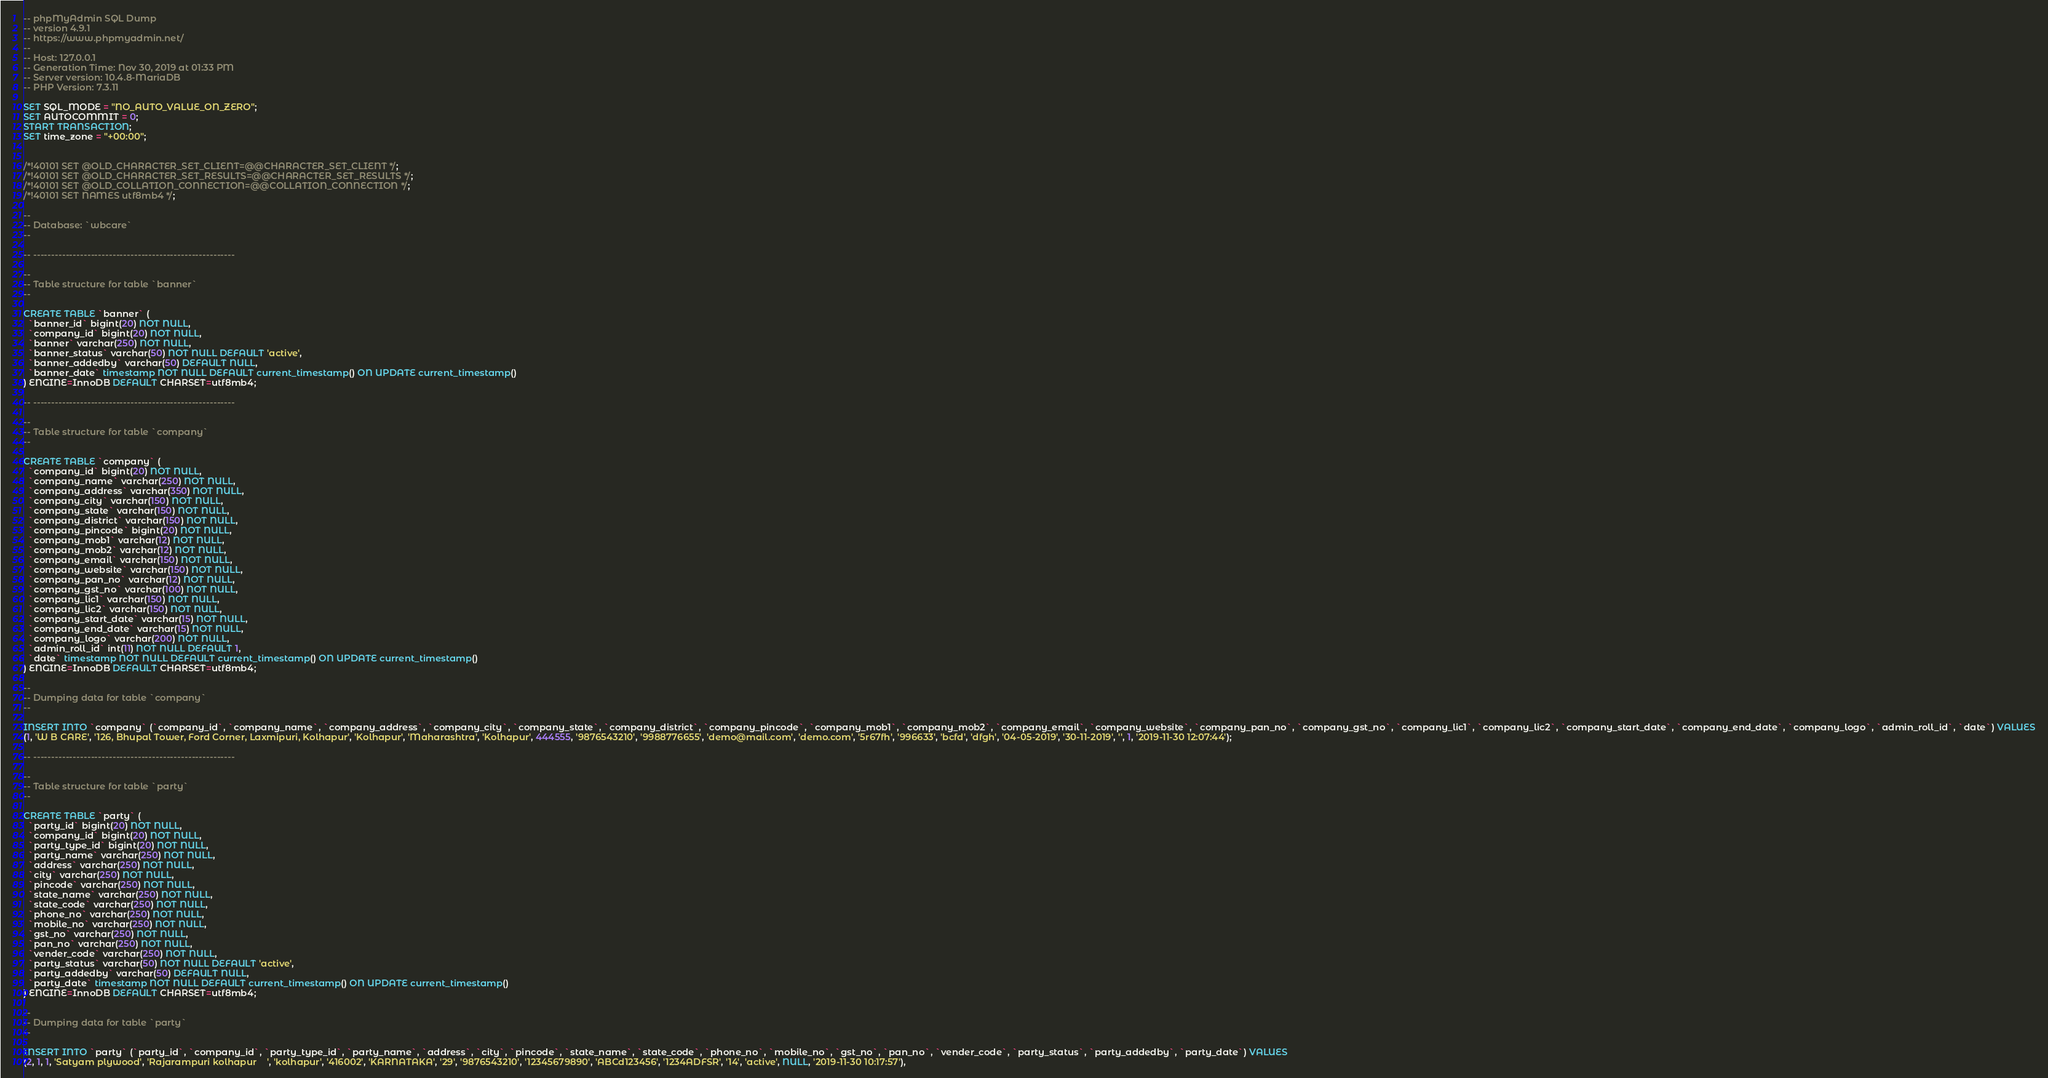<code> <loc_0><loc_0><loc_500><loc_500><_SQL_>-- phpMyAdmin SQL Dump
-- version 4.9.1
-- https://www.phpmyadmin.net/
--
-- Host: 127.0.0.1
-- Generation Time: Nov 30, 2019 at 01:33 PM
-- Server version: 10.4.8-MariaDB
-- PHP Version: 7.3.11

SET SQL_MODE = "NO_AUTO_VALUE_ON_ZERO";
SET AUTOCOMMIT = 0;
START TRANSACTION;
SET time_zone = "+00:00";


/*!40101 SET @OLD_CHARACTER_SET_CLIENT=@@CHARACTER_SET_CLIENT */;
/*!40101 SET @OLD_CHARACTER_SET_RESULTS=@@CHARACTER_SET_RESULTS */;
/*!40101 SET @OLD_COLLATION_CONNECTION=@@COLLATION_CONNECTION */;
/*!40101 SET NAMES utf8mb4 */;

--
-- Database: `wbcare`
--

-- --------------------------------------------------------

--
-- Table structure for table `banner`
--

CREATE TABLE `banner` (
  `banner_id` bigint(20) NOT NULL,
  `company_id` bigint(20) NOT NULL,
  `banner` varchar(250) NOT NULL,
  `banner_status` varchar(50) NOT NULL DEFAULT 'active',
  `banner_addedby` varchar(50) DEFAULT NULL,
  `banner_date` timestamp NOT NULL DEFAULT current_timestamp() ON UPDATE current_timestamp()
) ENGINE=InnoDB DEFAULT CHARSET=utf8mb4;

-- --------------------------------------------------------

--
-- Table structure for table `company`
--

CREATE TABLE `company` (
  `company_id` bigint(20) NOT NULL,
  `company_name` varchar(250) NOT NULL,
  `company_address` varchar(350) NOT NULL,
  `company_city` varchar(150) NOT NULL,
  `company_state` varchar(150) NOT NULL,
  `company_district` varchar(150) NOT NULL,
  `company_pincode` bigint(20) NOT NULL,
  `company_mob1` varchar(12) NOT NULL,
  `company_mob2` varchar(12) NOT NULL,
  `company_email` varchar(150) NOT NULL,
  `company_website` varchar(150) NOT NULL,
  `company_pan_no` varchar(12) NOT NULL,
  `company_gst_no` varchar(100) NOT NULL,
  `company_lic1` varchar(150) NOT NULL,
  `company_lic2` varchar(150) NOT NULL,
  `company_start_date` varchar(15) NOT NULL,
  `company_end_date` varchar(15) NOT NULL,
  `company_logo` varchar(200) NOT NULL,
  `admin_roll_id` int(11) NOT NULL DEFAULT 1,
  `date` timestamp NOT NULL DEFAULT current_timestamp() ON UPDATE current_timestamp()
) ENGINE=InnoDB DEFAULT CHARSET=utf8mb4;

--
-- Dumping data for table `company`
--

INSERT INTO `company` (`company_id`, `company_name`, `company_address`, `company_city`, `company_state`, `company_district`, `company_pincode`, `company_mob1`, `company_mob2`, `company_email`, `company_website`, `company_pan_no`, `company_gst_no`, `company_lic1`, `company_lic2`, `company_start_date`, `company_end_date`, `company_logo`, `admin_roll_id`, `date`) VALUES
(1, 'W B CARE', '126, Bhupal Tower, Ford Corner, Laxmipuri, Kolhapur', 'Kolhapur', 'Maharashtra', 'Kolhapur', 444555, '9876543210', '9988776655', 'demo@mail.com', 'demo.com', '5r67fh', '996633', 'bcfd', 'dfgh', '04-05-2019', '30-11-2019', '', 1, '2019-11-30 12:07:44');

-- --------------------------------------------------------

--
-- Table structure for table `party`
--

CREATE TABLE `party` (
  `party_id` bigint(20) NOT NULL,
  `company_id` bigint(20) NOT NULL,
  `party_type_id` bigint(20) NOT NULL,
  `party_name` varchar(250) NOT NULL,
  `address` varchar(250) NOT NULL,
  `city` varchar(250) NOT NULL,
  `pincode` varchar(250) NOT NULL,
  `state_name` varchar(250) NOT NULL,
  `state_code` varchar(250) NOT NULL,
  `phone_no` varchar(250) NOT NULL,
  `mobile_no` varchar(250) NOT NULL,
  `gst_no` varchar(250) NOT NULL,
  `pan_no` varchar(250) NOT NULL,
  `vender_code` varchar(250) NOT NULL,
  `party_status` varchar(50) NOT NULL DEFAULT 'active',
  `party_addedby` varchar(50) DEFAULT NULL,
  `party_date` timestamp NOT NULL DEFAULT current_timestamp() ON UPDATE current_timestamp()
) ENGINE=InnoDB DEFAULT CHARSET=utf8mb4;

--
-- Dumping data for table `party`
--

INSERT INTO `party` (`party_id`, `company_id`, `party_type_id`, `party_name`, `address`, `city`, `pincode`, `state_name`, `state_code`, `phone_no`, `mobile_no`, `gst_no`, `pan_no`, `vender_code`, `party_status`, `party_addedby`, `party_date`) VALUES
(2, 1, 1, 'Satyam plywood', 'Rajarampuri kolhapur    ', 'kolhapur', '416002', 'KARNATAKA', '29', '9876543210', '12345679890', 'ABCd123456', '1234ADFSR', '14', 'active', NULL, '2019-11-30 10:17:57'),</code> 